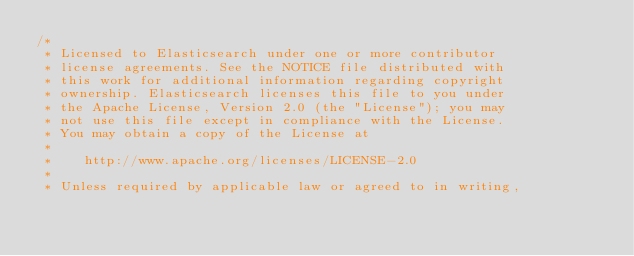<code> <loc_0><loc_0><loc_500><loc_500><_Java_>/*
 * Licensed to Elasticsearch under one or more contributor
 * license agreements. See the NOTICE file distributed with
 * this work for additional information regarding copyright
 * ownership. Elasticsearch licenses this file to you under
 * the Apache License, Version 2.0 (the "License"); you may
 * not use this file except in compliance with the License.
 * You may obtain a copy of the License at
 *
 *    http://www.apache.org/licenses/LICENSE-2.0
 *
 * Unless required by applicable law or agreed to in writing,</code> 